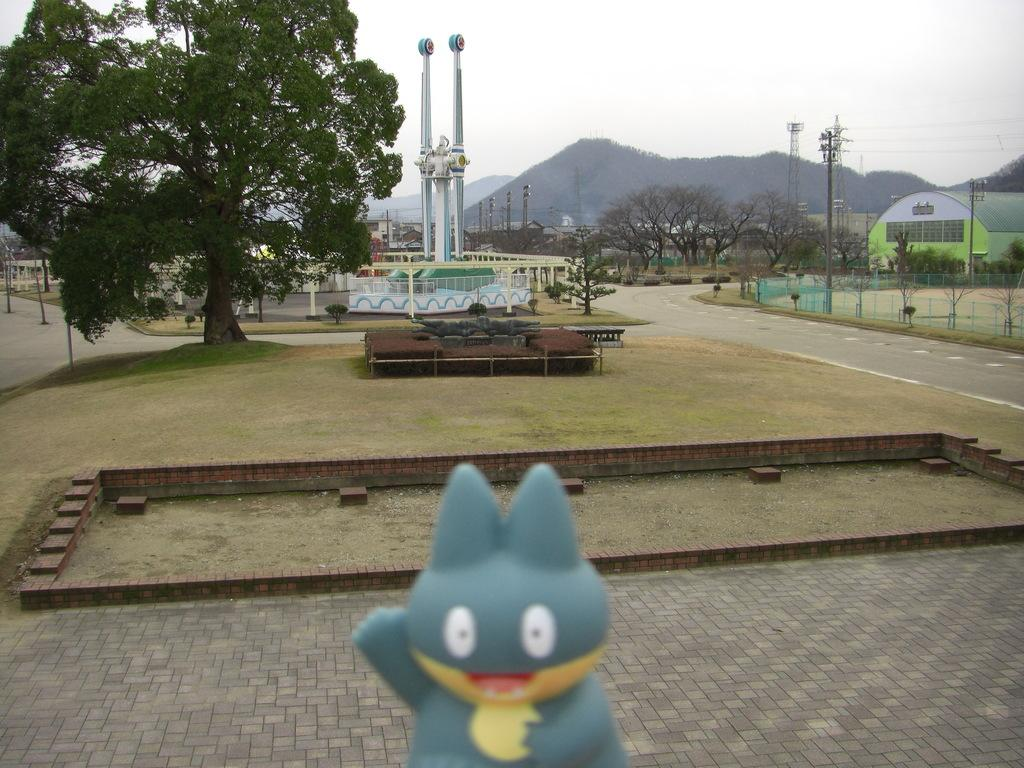What object can be seen in the image that is typically used for play or entertainment? There is a toy in the image. What type of surface is visible in the image? The ground is visible in the image. What type of structures are present in the image? There are sheds in the image. What type of vegetation is present in the image? Trees are present in the image. What type of vertical structures are visible in the image? Poles are visible in the image. What other unspecified objects can be seen in the image? There are unspecified objects in the image. What can be seen in the distance in the background of the image? There are mountains visible in the background of the image. What else is visible in the background of the image? The sky is visible in the background of the image. What nation is represented by the flag flying on the pole in the image? There is no flag visible on the pole in the image. What is the purpose of the mountains in the image? The mountains do not have a purpose in the image; they are a natural geographical feature visible in the background. 